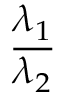<formula> <loc_0><loc_0><loc_500><loc_500>\frac { \lambda _ { 1 } } { \lambda _ { 2 } }</formula> 